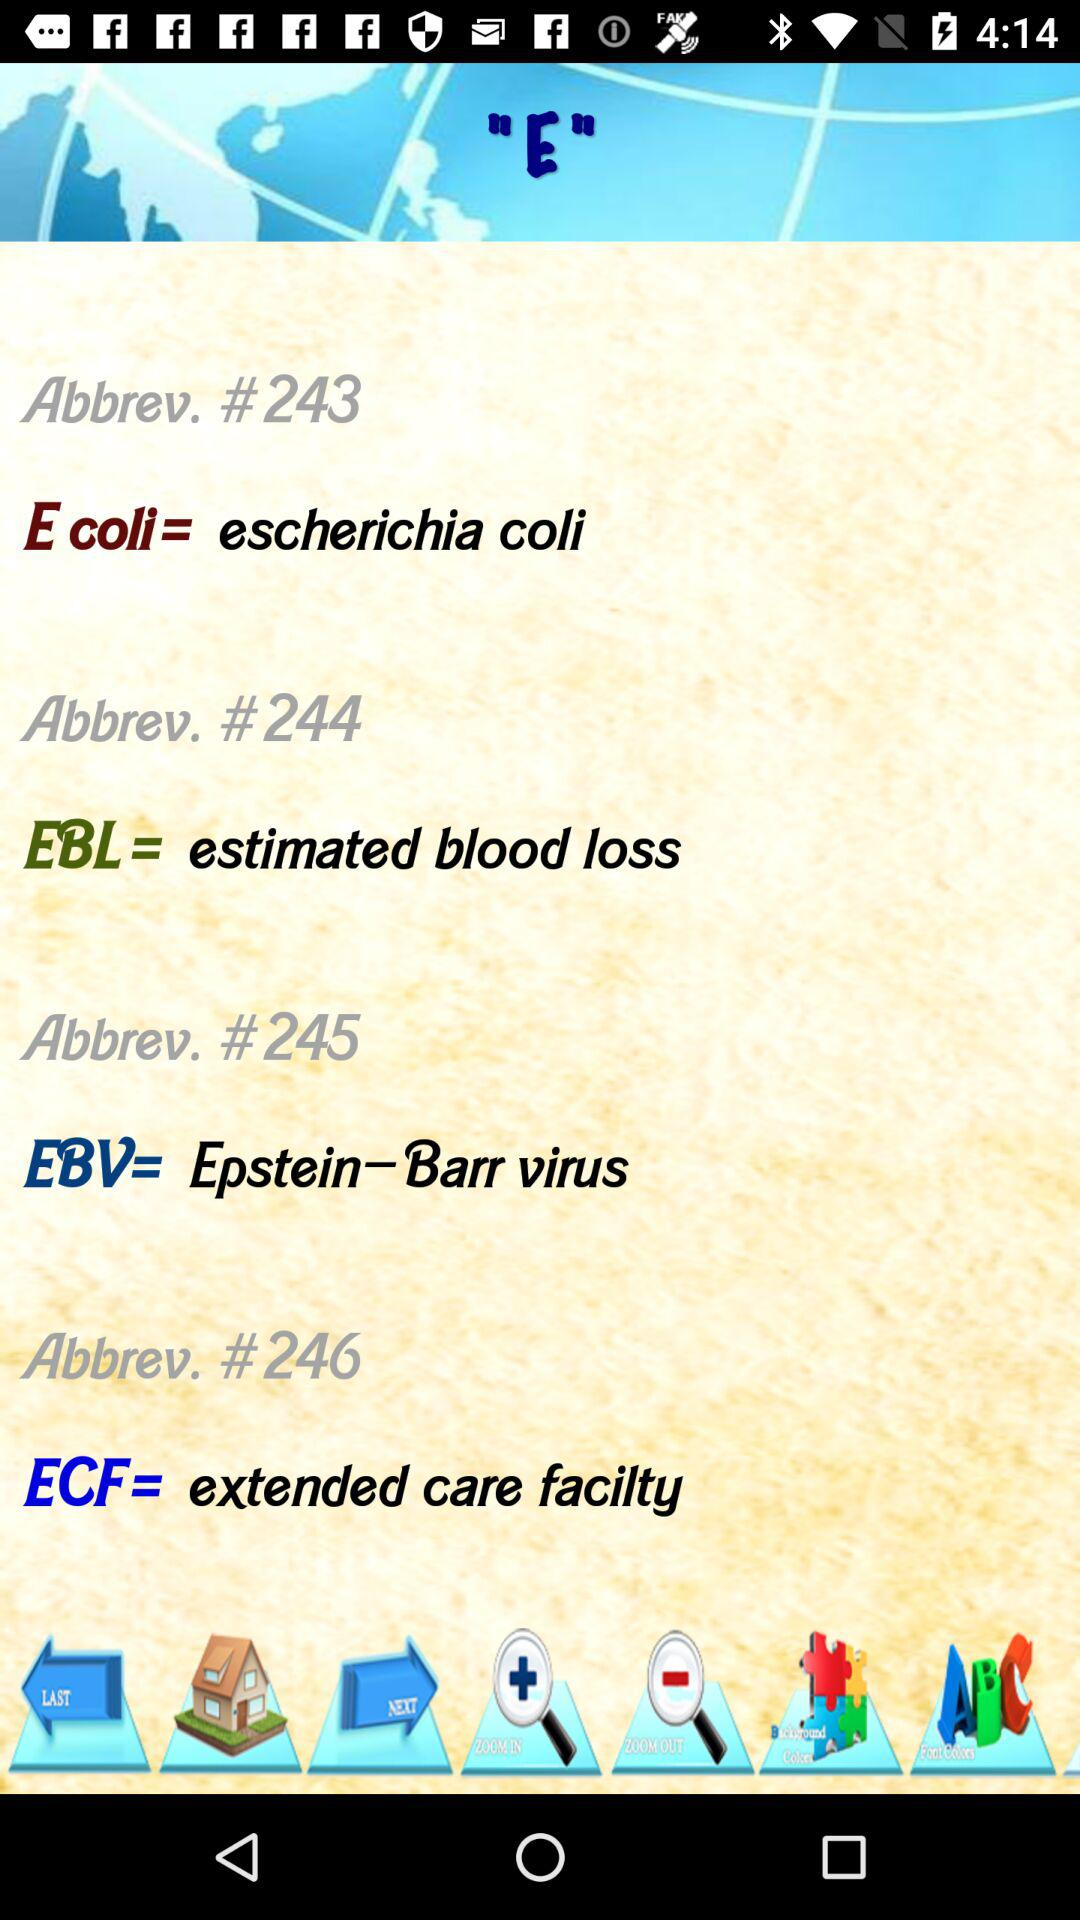What is the full form of ECF? The full form of ECF is Extended Care Facilty. 